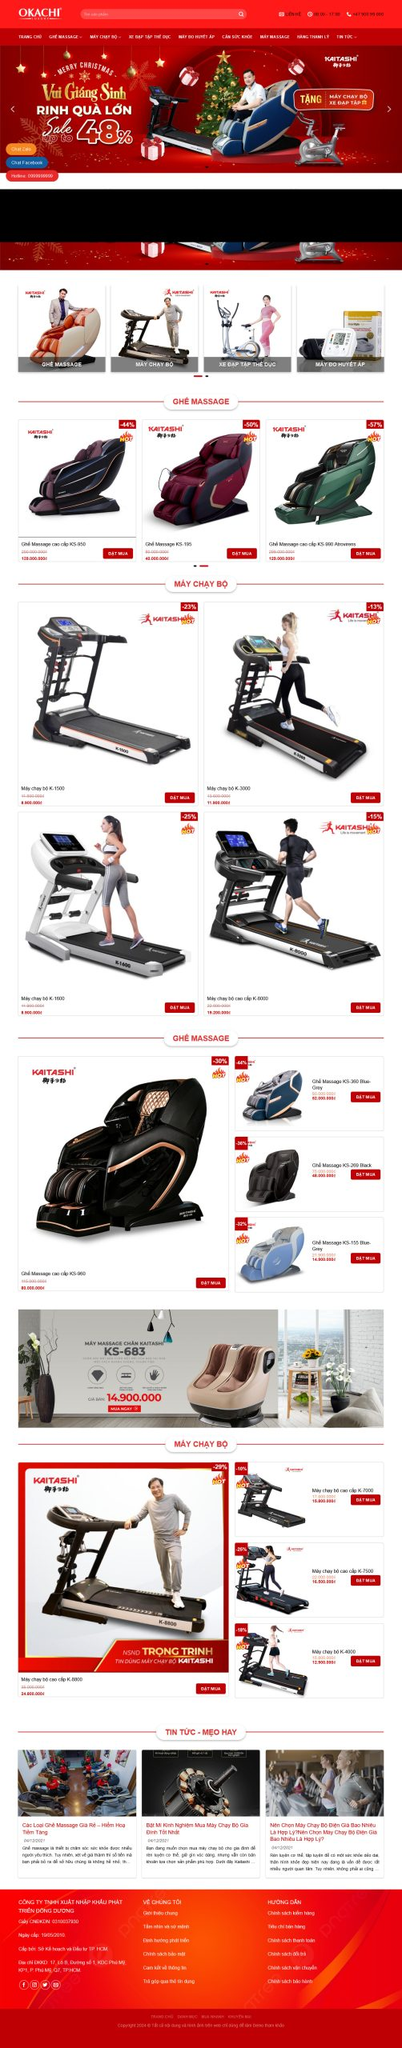Liệt kê 5 ngành nghề, lĩnh vực phù hợp với website này, phân cách các màu sắc bằng dấu phẩy. Chỉ trả về kết quả, phân cách bằng dấy phẩy
 Thể dục thể thao, Sức khỏe, Thiết bị gia đình, Thương mại điện tử, Dịch vụ chăm sóc sức khỏe 